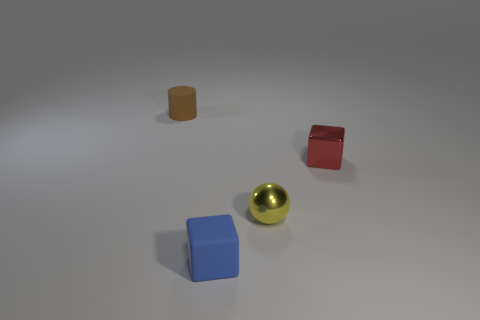How many other objects are there of the same material as the yellow thing?
Make the answer very short. 1. Is the number of things that are behind the tiny yellow sphere the same as the number of small shiny things right of the tiny cylinder?
Give a very brief answer. Yes. What number of red objects are either large balls or small metal cubes?
Ensure brevity in your answer.  1. What number of other objects are the same color as the tiny shiny sphere?
Offer a very short reply. 0. Is the number of small yellow things less than the number of gray matte blocks?
Your answer should be very brief. No. There is a thing that is on the left side of the tiny cube left of the yellow shiny ball; what number of small shiny blocks are in front of it?
Provide a succinct answer. 1. There is a rubber thing that is right of the brown object; what is its size?
Offer a terse response. Small. There is a rubber object behind the matte block; is it the same shape as the small yellow thing?
Offer a very short reply. No. What is the material of the other small object that is the same shape as the red thing?
Provide a succinct answer. Rubber. Are any small cylinders visible?
Offer a terse response. Yes. 